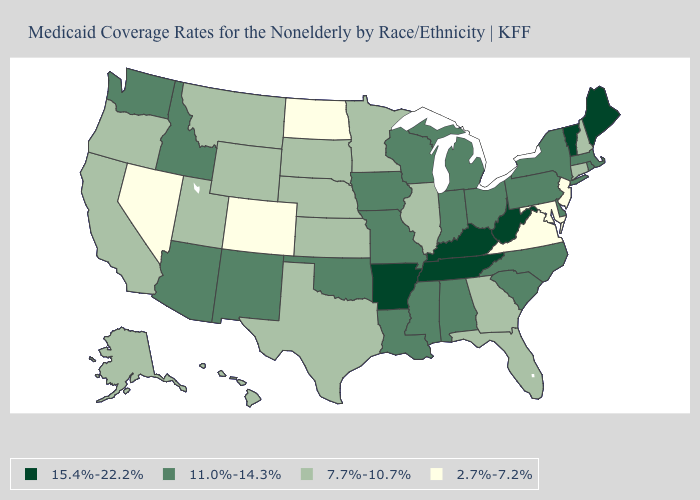What is the value of Indiana?
Answer briefly. 11.0%-14.3%. What is the value of South Carolina?
Keep it brief. 11.0%-14.3%. Does the first symbol in the legend represent the smallest category?
Concise answer only. No. What is the value of Maine?
Concise answer only. 15.4%-22.2%. What is the highest value in the MidWest ?
Answer briefly. 11.0%-14.3%. What is the value of Pennsylvania?
Be succinct. 11.0%-14.3%. What is the value of Maryland?
Concise answer only. 2.7%-7.2%. Name the states that have a value in the range 2.7%-7.2%?
Answer briefly. Colorado, Maryland, Nevada, New Jersey, North Dakota, Virginia. Does the first symbol in the legend represent the smallest category?
Answer briefly. No. How many symbols are there in the legend?
Be succinct. 4. What is the lowest value in the South?
Quick response, please. 2.7%-7.2%. What is the highest value in the MidWest ?
Answer briefly. 11.0%-14.3%. Does the first symbol in the legend represent the smallest category?
Concise answer only. No. Name the states that have a value in the range 2.7%-7.2%?
Keep it brief. Colorado, Maryland, Nevada, New Jersey, North Dakota, Virginia. Does Idaho have a higher value than Georgia?
Keep it brief. Yes. 